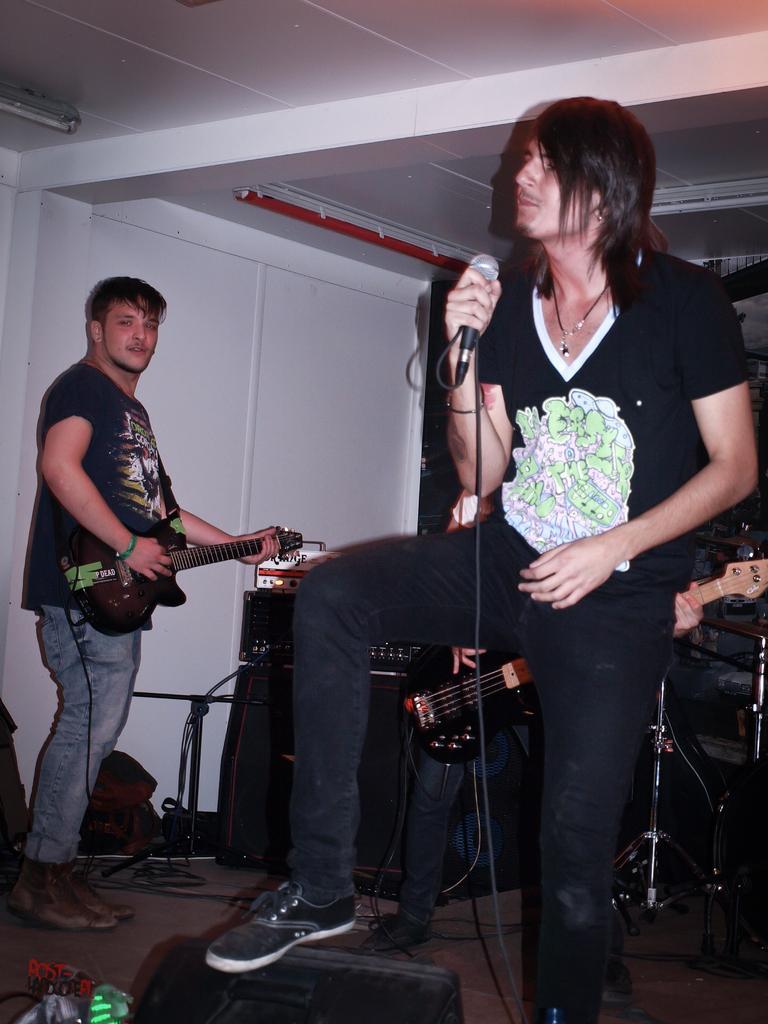Could you give a brief overview of what you see in this image? In the picture there are three persons total ,the first person is singing the song, the second person and third person are playing the guitar, in the background there is a music system beside that there is a white color wall. 